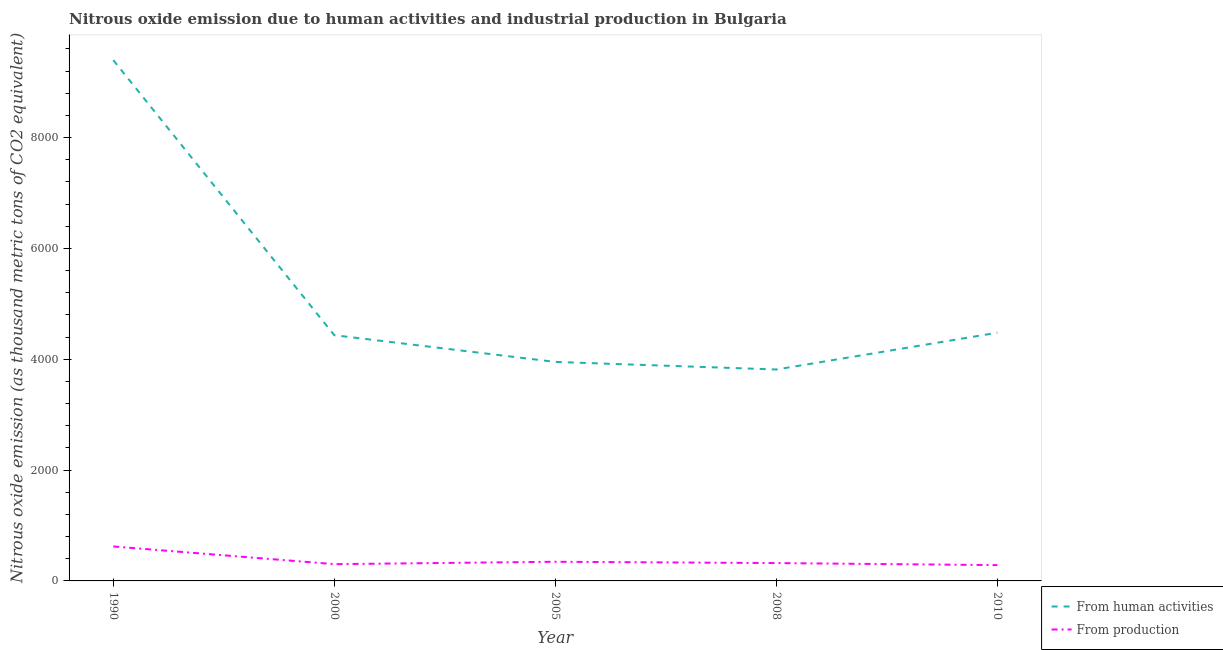How many different coloured lines are there?
Make the answer very short. 2. Does the line corresponding to amount of emissions generated from industries intersect with the line corresponding to amount of emissions from human activities?
Keep it short and to the point. No. Is the number of lines equal to the number of legend labels?
Offer a terse response. Yes. What is the amount of emissions from human activities in 2005?
Your answer should be compact. 3951.9. Across all years, what is the maximum amount of emissions generated from industries?
Offer a very short reply. 622. Across all years, what is the minimum amount of emissions from human activities?
Keep it short and to the point. 3815.2. In which year was the amount of emissions generated from industries minimum?
Your answer should be compact. 2010. What is the total amount of emissions from human activities in the graph?
Your answer should be very brief. 2.61e+04. What is the difference between the amount of emissions from human activities in 2000 and that in 2008?
Make the answer very short. 619. What is the difference between the amount of emissions from human activities in 2008 and the amount of emissions generated from industries in 2010?
Keep it short and to the point. 3529.8. What is the average amount of emissions generated from industries per year?
Give a very brief answer. 375.56. In the year 2010, what is the difference between the amount of emissions from human activities and amount of emissions generated from industries?
Keep it short and to the point. 4193.8. What is the ratio of the amount of emissions generated from industries in 2000 to that in 2008?
Keep it short and to the point. 0.94. What is the difference between the highest and the second highest amount of emissions from human activities?
Offer a terse response. 4918.8. What is the difference between the highest and the lowest amount of emissions generated from industries?
Provide a succinct answer. 336.6. In how many years, is the amount of emissions from human activities greater than the average amount of emissions from human activities taken over all years?
Offer a terse response. 1. Is the amount of emissions from human activities strictly greater than the amount of emissions generated from industries over the years?
Ensure brevity in your answer.  Yes. How many lines are there?
Provide a short and direct response. 2. What is the difference between two consecutive major ticks on the Y-axis?
Your answer should be very brief. 2000. Where does the legend appear in the graph?
Your answer should be very brief. Bottom right. How are the legend labels stacked?
Your answer should be very brief. Vertical. What is the title of the graph?
Offer a very short reply. Nitrous oxide emission due to human activities and industrial production in Bulgaria. What is the label or title of the X-axis?
Provide a short and direct response. Year. What is the label or title of the Y-axis?
Your response must be concise. Nitrous oxide emission (as thousand metric tons of CO2 equivalent). What is the Nitrous oxide emission (as thousand metric tons of CO2 equivalent) of From human activities in 1990?
Keep it short and to the point. 9398. What is the Nitrous oxide emission (as thousand metric tons of CO2 equivalent) in From production in 1990?
Your answer should be compact. 622. What is the Nitrous oxide emission (as thousand metric tons of CO2 equivalent) in From human activities in 2000?
Your answer should be very brief. 4434.2. What is the Nitrous oxide emission (as thousand metric tons of CO2 equivalent) of From production in 2000?
Your response must be concise. 302.6. What is the Nitrous oxide emission (as thousand metric tons of CO2 equivalent) of From human activities in 2005?
Offer a very short reply. 3951.9. What is the Nitrous oxide emission (as thousand metric tons of CO2 equivalent) of From production in 2005?
Your answer should be very brief. 345.8. What is the Nitrous oxide emission (as thousand metric tons of CO2 equivalent) in From human activities in 2008?
Ensure brevity in your answer.  3815.2. What is the Nitrous oxide emission (as thousand metric tons of CO2 equivalent) in From production in 2008?
Ensure brevity in your answer.  322. What is the Nitrous oxide emission (as thousand metric tons of CO2 equivalent) of From human activities in 2010?
Your answer should be compact. 4479.2. What is the Nitrous oxide emission (as thousand metric tons of CO2 equivalent) of From production in 2010?
Offer a terse response. 285.4. Across all years, what is the maximum Nitrous oxide emission (as thousand metric tons of CO2 equivalent) in From human activities?
Make the answer very short. 9398. Across all years, what is the maximum Nitrous oxide emission (as thousand metric tons of CO2 equivalent) of From production?
Your response must be concise. 622. Across all years, what is the minimum Nitrous oxide emission (as thousand metric tons of CO2 equivalent) of From human activities?
Make the answer very short. 3815.2. Across all years, what is the minimum Nitrous oxide emission (as thousand metric tons of CO2 equivalent) of From production?
Ensure brevity in your answer.  285.4. What is the total Nitrous oxide emission (as thousand metric tons of CO2 equivalent) of From human activities in the graph?
Keep it short and to the point. 2.61e+04. What is the total Nitrous oxide emission (as thousand metric tons of CO2 equivalent) in From production in the graph?
Keep it short and to the point. 1877.8. What is the difference between the Nitrous oxide emission (as thousand metric tons of CO2 equivalent) in From human activities in 1990 and that in 2000?
Offer a terse response. 4963.8. What is the difference between the Nitrous oxide emission (as thousand metric tons of CO2 equivalent) of From production in 1990 and that in 2000?
Offer a very short reply. 319.4. What is the difference between the Nitrous oxide emission (as thousand metric tons of CO2 equivalent) in From human activities in 1990 and that in 2005?
Offer a very short reply. 5446.1. What is the difference between the Nitrous oxide emission (as thousand metric tons of CO2 equivalent) of From production in 1990 and that in 2005?
Provide a short and direct response. 276.2. What is the difference between the Nitrous oxide emission (as thousand metric tons of CO2 equivalent) of From human activities in 1990 and that in 2008?
Ensure brevity in your answer.  5582.8. What is the difference between the Nitrous oxide emission (as thousand metric tons of CO2 equivalent) in From production in 1990 and that in 2008?
Your response must be concise. 300. What is the difference between the Nitrous oxide emission (as thousand metric tons of CO2 equivalent) of From human activities in 1990 and that in 2010?
Keep it short and to the point. 4918.8. What is the difference between the Nitrous oxide emission (as thousand metric tons of CO2 equivalent) in From production in 1990 and that in 2010?
Keep it short and to the point. 336.6. What is the difference between the Nitrous oxide emission (as thousand metric tons of CO2 equivalent) of From human activities in 2000 and that in 2005?
Offer a very short reply. 482.3. What is the difference between the Nitrous oxide emission (as thousand metric tons of CO2 equivalent) in From production in 2000 and that in 2005?
Offer a terse response. -43.2. What is the difference between the Nitrous oxide emission (as thousand metric tons of CO2 equivalent) in From human activities in 2000 and that in 2008?
Provide a succinct answer. 619. What is the difference between the Nitrous oxide emission (as thousand metric tons of CO2 equivalent) of From production in 2000 and that in 2008?
Give a very brief answer. -19.4. What is the difference between the Nitrous oxide emission (as thousand metric tons of CO2 equivalent) of From human activities in 2000 and that in 2010?
Your answer should be compact. -45. What is the difference between the Nitrous oxide emission (as thousand metric tons of CO2 equivalent) of From production in 2000 and that in 2010?
Offer a very short reply. 17.2. What is the difference between the Nitrous oxide emission (as thousand metric tons of CO2 equivalent) of From human activities in 2005 and that in 2008?
Keep it short and to the point. 136.7. What is the difference between the Nitrous oxide emission (as thousand metric tons of CO2 equivalent) in From production in 2005 and that in 2008?
Your answer should be compact. 23.8. What is the difference between the Nitrous oxide emission (as thousand metric tons of CO2 equivalent) of From human activities in 2005 and that in 2010?
Offer a terse response. -527.3. What is the difference between the Nitrous oxide emission (as thousand metric tons of CO2 equivalent) of From production in 2005 and that in 2010?
Provide a succinct answer. 60.4. What is the difference between the Nitrous oxide emission (as thousand metric tons of CO2 equivalent) of From human activities in 2008 and that in 2010?
Give a very brief answer. -664. What is the difference between the Nitrous oxide emission (as thousand metric tons of CO2 equivalent) in From production in 2008 and that in 2010?
Make the answer very short. 36.6. What is the difference between the Nitrous oxide emission (as thousand metric tons of CO2 equivalent) in From human activities in 1990 and the Nitrous oxide emission (as thousand metric tons of CO2 equivalent) in From production in 2000?
Offer a terse response. 9095.4. What is the difference between the Nitrous oxide emission (as thousand metric tons of CO2 equivalent) of From human activities in 1990 and the Nitrous oxide emission (as thousand metric tons of CO2 equivalent) of From production in 2005?
Offer a terse response. 9052.2. What is the difference between the Nitrous oxide emission (as thousand metric tons of CO2 equivalent) of From human activities in 1990 and the Nitrous oxide emission (as thousand metric tons of CO2 equivalent) of From production in 2008?
Your answer should be very brief. 9076. What is the difference between the Nitrous oxide emission (as thousand metric tons of CO2 equivalent) in From human activities in 1990 and the Nitrous oxide emission (as thousand metric tons of CO2 equivalent) in From production in 2010?
Provide a succinct answer. 9112.6. What is the difference between the Nitrous oxide emission (as thousand metric tons of CO2 equivalent) of From human activities in 2000 and the Nitrous oxide emission (as thousand metric tons of CO2 equivalent) of From production in 2005?
Your answer should be very brief. 4088.4. What is the difference between the Nitrous oxide emission (as thousand metric tons of CO2 equivalent) of From human activities in 2000 and the Nitrous oxide emission (as thousand metric tons of CO2 equivalent) of From production in 2008?
Keep it short and to the point. 4112.2. What is the difference between the Nitrous oxide emission (as thousand metric tons of CO2 equivalent) of From human activities in 2000 and the Nitrous oxide emission (as thousand metric tons of CO2 equivalent) of From production in 2010?
Give a very brief answer. 4148.8. What is the difference between the Nitrous oxide emission (as thousand metric tons of CO2 equivalent) of From human activities in 2005 and the Nitrous oxide emission (as thousand metric tons of CO2 equivalent) of From production in 2008?
Give a very brief answer. 3629.9. What is the difference between the Nitrous oxide emission (as thousand metric tons of CO2 equivalent) in From human activities in 2005 and the Nitrous oxide emission (as thousand metric tons of CO2 equivalent) in From production in 2010?
Keep it short and to the point. 3666.5. What is the difference between the Nitrous oxide emission (as thousand metric tons of CO2 equivalent) of From human activities in 2008 and the Nitrous oxide emission (as thousand metric tons of CO2 equivalent) of From production in 2010?
Provide a short and direct response. 3529.8. What is the average Nitrous oxide emission (as thousand metric tons of CO2 equivalent) of From human activities per year?
Ensure brevity in your answer.  5215.7. What is the average Nitrous oxide emission (as thousand metric tons of CO2 equivalent) in From production per year?
Your answer should be very brief. 375.56. In the year 1990, what is the difference between the Nitrous oxide emission (as thousand metric tons of CO2 equivalent) of From human activities and Nitrous oxide emission (as thousand metric tons of CO2 equivalent) of From production?
Your answer should be compact. 8776. In the year 2000, what is the difference between the Nitrous oxide emission (as thousand metric tons of CO2 equivalent) of From human activities and Nitrous oxide emission (as thousand metric tons of CO2 equivalent) of From production?
Your answer should be very brief. 4131.6. In the year 2005, what is the difference between the Nitrous oxide emission (as thousand metric tons of CO2 equivalent) of From human activities and Nitrous oxide emission (as thousand metric tons of CO2 equivalent) of From production?
Your response must be concise. 3606.1. In the year 2008, what is the difference between the Nitrous oxide emission (as thousand metric tons of CO2 equivalent) of From human activities and Nitrous oxide emission (as thousand metric tons of CO2 equivalent) of From production?
Keep it short and to the point. 3493.2. In the year 2010, what is the difference between the Nitrous oxide emission (as thousand metric tons of CO2 equivalent) of From human activities and Nitrous oxide emission (as thousand metric tons of CO2 equivalent) of From production?
Ensure brevity in your answer.  4193.8. What is the ratio of the Nitrous oxide emission (as thousand metric tons of CO2 equivalent) of From human activities in 1990 to that in 2000?
Provide a short and direct response. 2.12. What is the ratio of the Nitrous oxide emission (as thousand metric tons of CO2 equivalent) in From production in 1990 to that in 2000?
Keep it short and to the point. 2.06. What is the ratio of the Nitrous oxide emission (as thousand metric tons of CO2 equivalent) of From human activities in 1990 to that in 2005?
Your answer should be compact. 2.38. What is the ratio of the Nitrous oxide emission (as thousand metric tons of CO2 equivalent) of From production in 1990 to that in 2005?
Keep it short and to the point. 1.8. What is the ratio of the Nitrous oxide emission (as thousand metric tons of CO2 equivalent) of From human activities in 1990 to that in 2008?
Provide a succinct answer. 2.46. What is the ratio of the Nitrous oxide emission (as thousand metric tons of CO2 equivalent) of From production in 1990 to that in 2008?
Ensure brevity in your answer.  1.93. What is the ratio of the Nitrous oxide emission (as thousand metric tons of CO2 equivalent) of From human activities in 1990 to that in 2010?
Ensure brevity in your answer.  2.1. What is the ratio of the Nitrous oxide emission (as thousand metric tons of CO2 equivalent) in From production in 1990 to that in 2010?
Your answer should be very brief. 2.18. What is the ratio of the Nitrous oxide emission (as thousand metric tons of CO2 equivalent) in From human activities in 2000 to that in 2005?
Make the answer very short. 1.12. What is the ratio of the Nitrous oxide emission (as thousand metric tons of CO2 equivalent) in From production in 2000 to that in 2005?
Give a very brief answer. 0.88. What is the ratio of the Nitrous oxide emission (as thousand metric tons of CO2 equivalent) in From human activities in 2000 to that in 2008?
Ensure brevity in your answer.  1.16. What is the ratio of the Nitrous oxide emission (as thousand metric tons of CO2 equivalent) of From production in 2000 to that in 2008?
Your response must be concise. 0.94. What is the ratio of the Nitrous oxide emission (as thousand metric tons of CO2 equivalent) of From human activities in 2000 to that in 2010?
Make the answer very short. 0.99. What is the ratio of the Nitrous oxide emission (as thousand metric tons of CO2 equivalent) of From production in 2000 to that in 2010?
Offer a terse response. 1.06. What is the ratio of the Nitrous oxide emission (as thousand metric tons of CO2 equivalent) of From human activities in 2005 to that in 2008?
Keep it short and to the point. 1.04. What is the ratio of the Nitrous oxide emission (as thousand metric tons of CO2 equivalent) in From production in 2005 to that in 2008?
Give a very brief answer. 1.07. What is the ratio of the Nitrous oxide emission (as thousand metric tons of CO2 equivalent) in From human activities in 2005 to that in 2010?
Provide a succinct answer. 0.88. What is the ratio of the Nitrous oxide emission (as thousand metric tons of CO2 equivalent) of From production in 2005 to that in 2010?
Offer a terse response. 1.21. What is the ratio of the Nitrous oxide emission (as thousand metric tons of CO2 equivalent) of From human activities in 2008 to that in 2010?
Offer a very short reply. 0.85. What is the ratio of the Nitrous oxide emission (as thousand metric tons of CO2 equivalent) in From production in 2008 to that in 2010?
Offer a terse response. 1.13. What is the difference between the highest and the second highest Nitrous oxide emission (as thousand metric tons of CO2 equivalent) in From human activities?
Make the answer very short. 4918.8. What is the difference between the highest and the second highest Nitrous oxide emission (as thousand metric tons of CO2 equivalent) of From production?
Offer a very short reply. 276.2. What is the difference between the highest and the lowest Nitrous oxide emission (as thousand metric tons of CO2 equivalent) of From human activities?
Ensure brevity in your answer.  5582.8. What is the difference between the highest and the lowest Nitrous oxide emission (as thousand metric tons of CO2 equivalent) in From production?
Provide a succinct answer. 336.6. 